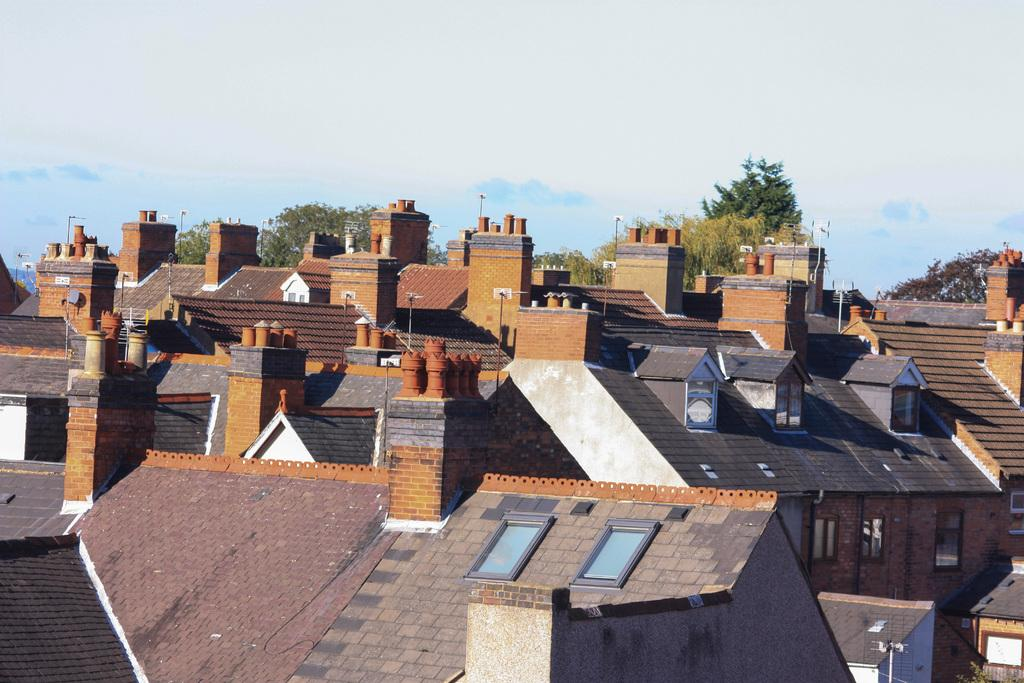What type of structures can be seen in the image? There are many houses in the image. What type of vegetation is visible in the background of the image? There are trees in the background of the image. What is visible at the top of the image? The sky is visible at the top of the image. Where is the harbor located in the image? There is no harbor present in the image. What type of trail can be seen winding through the houses in the image? There is no trail visible in the image; it only features houses and trees in the background. 